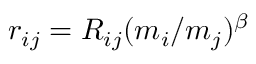Convert formula to latex. <formula><loc_0><loc_0><loc_500><loc_500>r _ { i j } = R _ { i j } ( m _ { i } / m _ { j } ) ^ { \beta }</formula> 